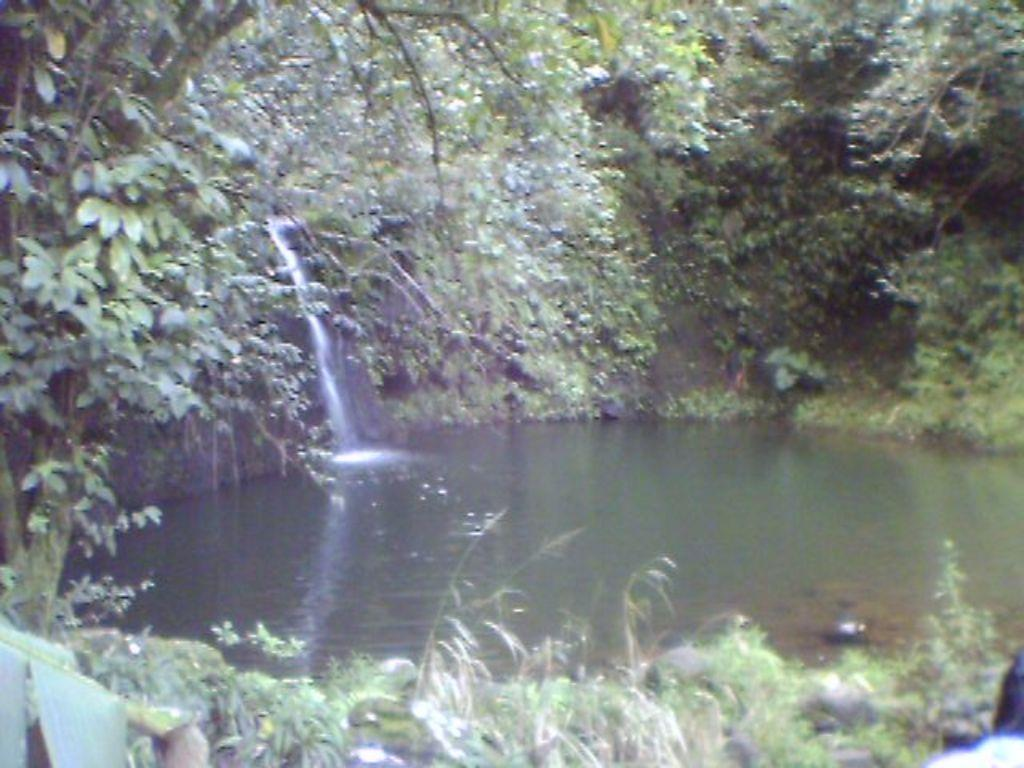What natural feature is the main subject of the image? There is a waterfall in the image. What is the result of the waterfall in the image? There is water at the bottom of the waterfall. What type of vegetation can be seen in the background of the image? There are trees in the background of the image. What type of ground cover is present at the bottom of the image? There is grass at the bottom of the image. What type of brake can be seen on the cart in the image? There is no cart present in the image, so there is no brake to be seen. 